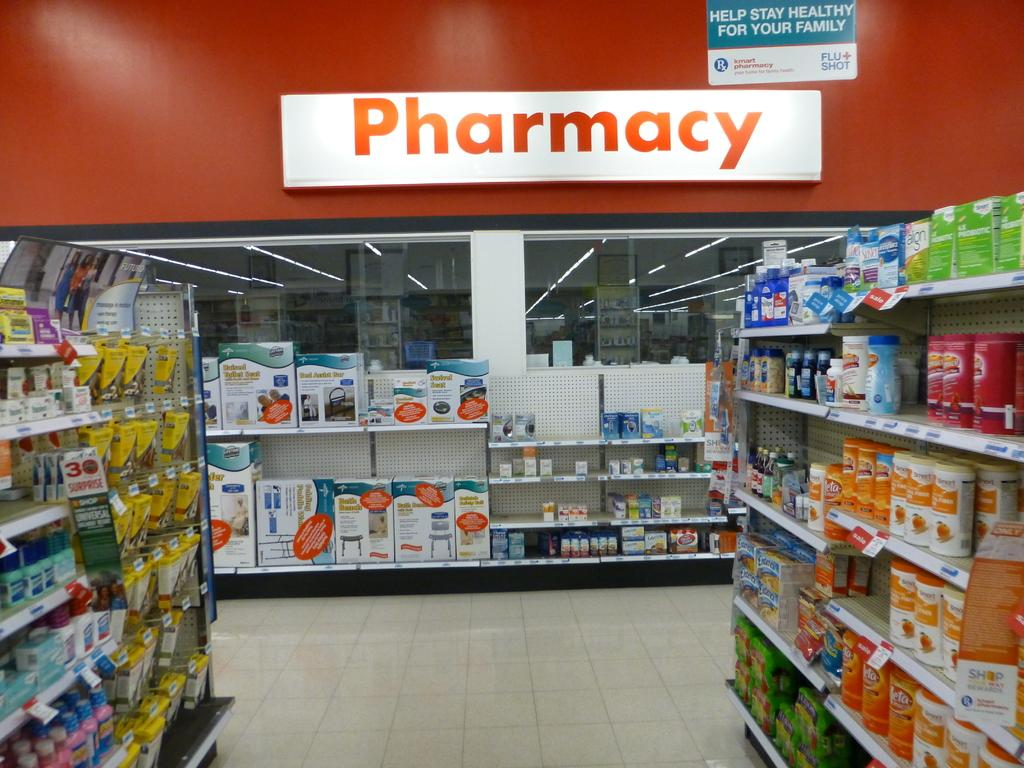<image>
Write a terse but informative summary of the picture. A section of a store that has a Pharmacy sign written on the wall. 